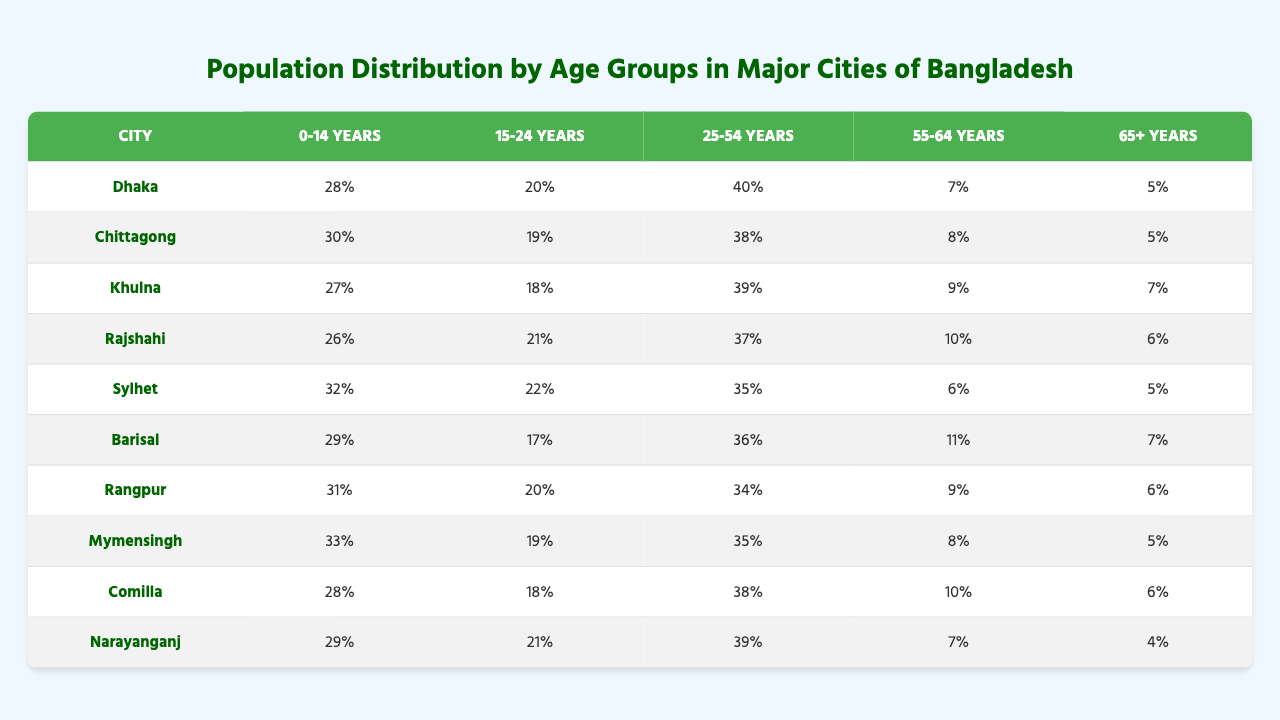What is the percentage of the population aged 0-14 years in Dhaka? In the table, under the "0-14 years" column corresponding to Dhaka, the value is "28%."
Answer: 28% Which city has the highest percentage of the population in the age group of 15-24 years? By comparing the values in the "15-24 years" column, Sylhet has the highest percentage with "22%."
Answer: Sylhet What is the total percentage of the population in the age groups of 25-54 years for all cities? To find the total, we sum up the percentages in the "25-54 years" column: (40 + 38 + 39 + 37 + 35 + 36 + 34 + 35 + 38 + 39) =  391%.
Answer: 391% Is there any city where the percentage of the population aged 65 years and over exceeds 7%? Looking at the "65+ years" column, Khulna, Barisal, and Rajshahi all have percentages greater than 7%—7% in Khulna, 7% in Barisal, and 6% in Rajshahi. This confirms several cities exceed 7%.
Answer: Yes Which city has a similar percentage of the population aged 55-64 years compared to Dhaka? Comparing the "55-64 years" percentages, Chittagong (8%) and Dhaka (7%) are relatively close, but Sylhet is somewhat far at 6%.
Answer: Chittagong What is the average percentage of the population aged 0-14 years across all cities? To find the average, sum the "0-14 years" percentages (28 + 30 + 27 + 26 + 32 + 29 + 31 + 33 + 28 + 29) =  293%, and then divide by the total number of cities (10): 293% / 10 = 29.3%.
Answer: 29.3% Which city has the least percentage of individuals aged 15-24 years? The least percentage in the "15-24 years" column is found in Khulna, where it is "18%."
Answer: Khulna What percentage of the population in Narayanganj is aged 55-64 years? Referring to the "55-64 years" column for Narayanganj, the value is "7%."
Answer: 7% If you combine the population percentages aged 55-64 and 65+ years for Rajshahi, what is the total? The percentages in the "55-64 years" and "65+ years" columns for Rajshahi are 10% and 6%, respectively. Adding these gives 10% + 6% = 16%.
Answer: 16% Is the population aged 25-54 years greater in Chittagong or Khulna? For age group 25-54 years, Chittagong has 38% while Khulna has 39%. Therefore, Khulna is greater.
Answer: Khulna What is the percentage difference in the age group of 0-14 years between Rangpur and Mymensingh? Rangpur has 31% and Mymensingh has 33% in the "0-14 years" column. The difference is calculated as 33% - 31% = 2%.
Answer: 2% 